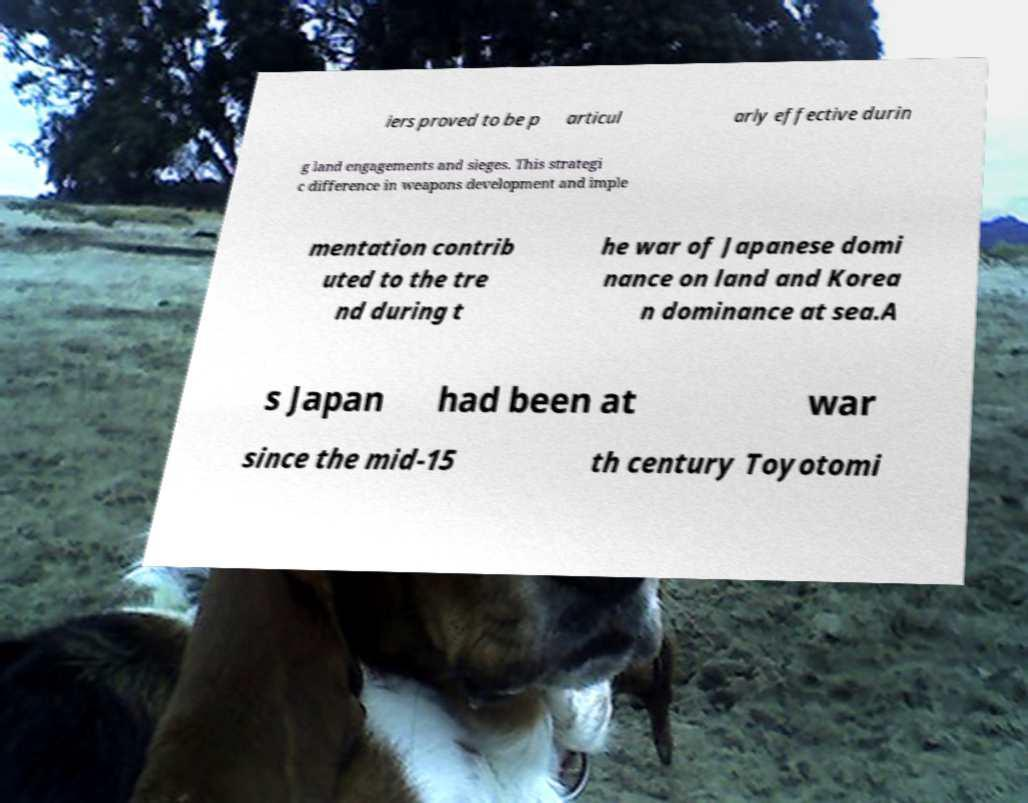Could you extract and type out the text from this image? iers proved to be p articul arly effective durin g land engagements and sieges. This strategi c difference in weapons development and imple mentation contrib uted to the tre nd during t he war of Japanese domi nance on land and Korea n dominance at sea.A s Japan had been at war since the mid-15 th century Toyotomi 